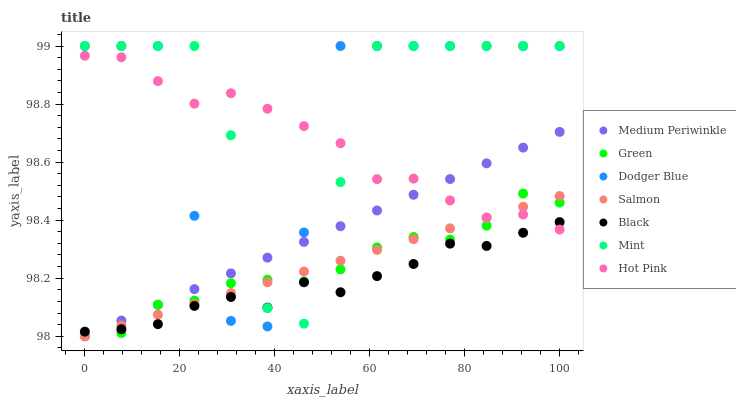Does Black have the minimum area under the curve?
Answer yes or no. Yes. Does Mint have the maximum area under the curve?
Answer yes or no. Yes. Does Hot Pink have the minimum area under the curve?
Answer yes or no. No. Does Hot Pink have the maximum area under the curve?
Answer yes or no. No. Is Salmon the smoothest?
Answer yes or no. Yes. Is Dodger Blue the roughest?
Answer yes or no. Yes. Is Hot Pink the smoothest?
Answer yes or no. No. Is Hot Pink the roughest?
Answer yes or no. No. Does Salmon have the lowest value?
Answer yes or no. Yes. Does Hot Pink have the lowest value?
Answer yes or no. No. Does Mint have the highest value?
Answer yes or no. Yes. Does Hot Pink have the highest value?
Answer yes or no. No. Does Medium Periwinkle intersect Salmon?
Answer yes or no. Yes. Is Medium Periwinkle less than Salmon?
Answer yes or no. No. Is Medium Periwinkle greater than Salmon?
Answer yes or no. No. 